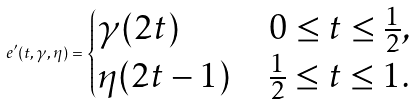<formula> <loc_0><loc_0><loc_500><loc_500>e ^ { \prime } ( t , \gamma , \eta ) = \begin{cases} \gamma ( 2 t ) & 0 \leq t \leq \frac { 1 } { 2 } , \\ \eta ( 2 t - 1 ) & \frac { 1 } { 2 } \leq t \leq 1 . \end{cases}</formula> 